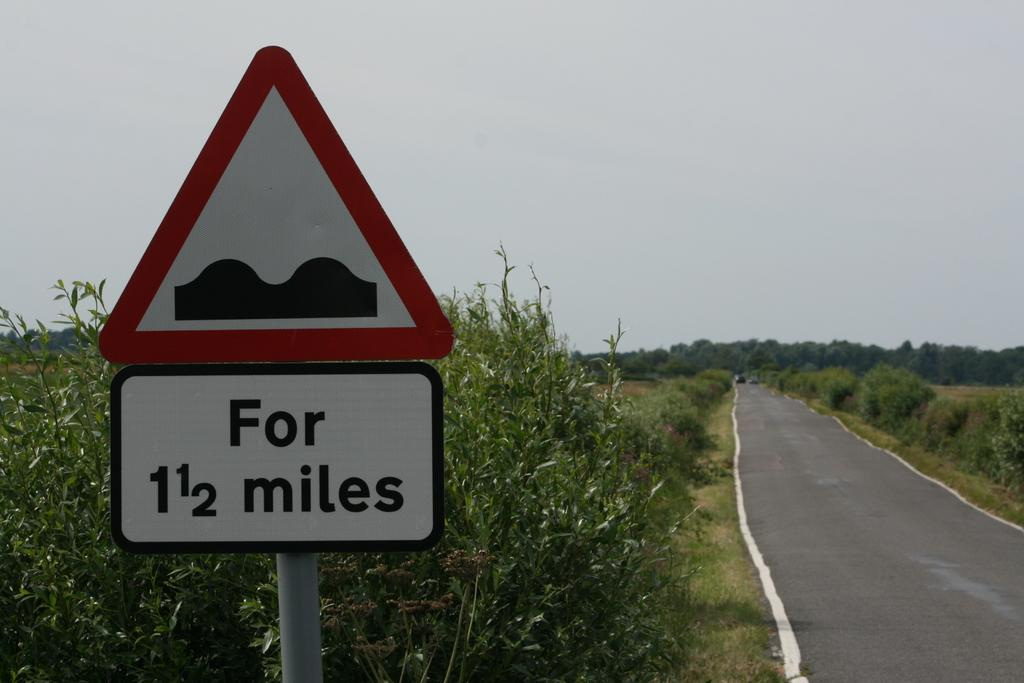<image>
Give a short and clear explanation of the subsequent image. A sign on a road warns of bumpy conditions for the next 1.5 miles. 